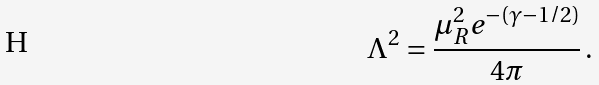Convert formula to latex. <formula><loc_0><loc_0><loc_500><loc_500>\Lambda ^ { 2 } = \frac { \mu _ { R } ^ { 2 } e ^ { - ( \gamma - 1 / 2 ) } } { 4 \pi } \, .</formula> 